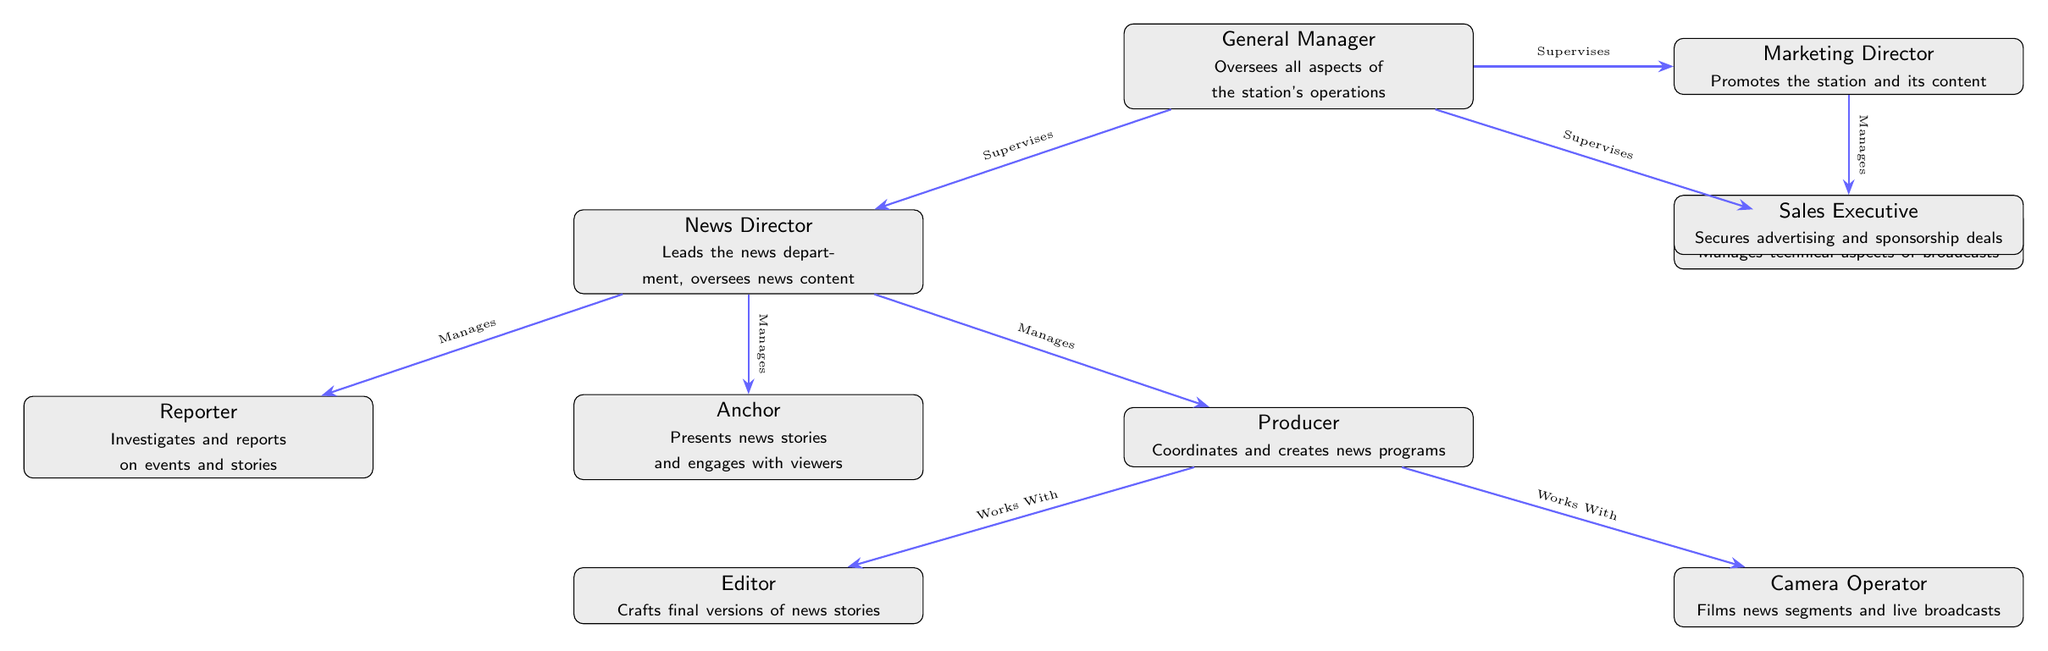What's the role of the General Manager? The General Manager oversees all aspects of the station's operations, which is stated directly in the node representing the General Manager.
Answer: Oversees all aspects of the station's operations How many nodes are under the News Director? The News Director manages three nodes: Anchor, Reporter, and Producer, which appear directly below the News Director node.
Answer: 3 Who works with the Producer? The Producer works with the Editor and the Camera Operator, which are both positioned below and to the sides of the Producer node, indicating their collaborative relationship.
Answer: Editor and Camera Operator What is the relationship between the Technical Director and the General Manager? The Technical Director is supervised by the General Manager, as indicated by the edge connecting these two nodes with the label "Supervises."
Answer: Supervises Which role is directly responsible for securing advertising deals? The Sales Executive is the role directly responsible for securing advertising and sponsorship deals, as stated in the Sales Executive node, which is positioned below the Marketing Director.
Answer: Sales Executive What is the main function of the Marketing Director? The Marketing Director promotes the station and its content, which is specified directly in the node describing the Marketing Director.
Answer: Promotes the station and its content How many edges connect the General Manager to other nodes? The General Manager is connected to three other nodes: News Director, Technical Director, and Marketing Director, resulting in three edges.
Answer: 3 Which position is specifically tasked with crafting final versions of news stories? The Editor is tasked with crafting final versions of news stories, as clearly mentioned in the node that describes the Editor role.
Answer: Editor What do the arrows between nodes signify? The arrows between nodes signify the relationships and the flow of management or collaboration between different roles in the organizational structure.
Answer: Relationships and flow of management 